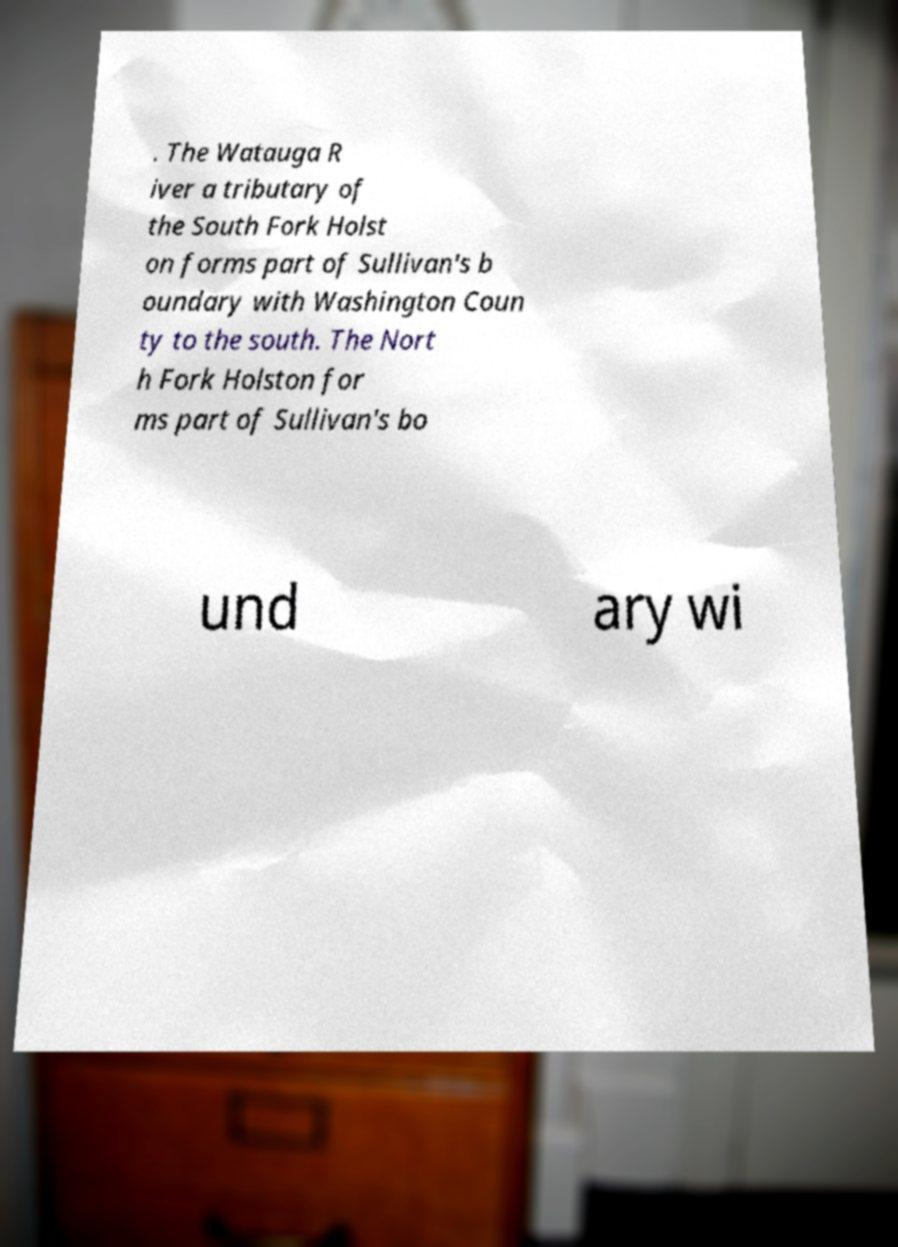What messages or text are displayed in this image? I need them in a readable, typed format. . The Watauga R iver a tributary of the South Fork Holst on forms part of Sullivan's b oundary with Washington Coun ty to the south. The Nort h Fork Holston for ms part of Sullivan's bo und ary wi 